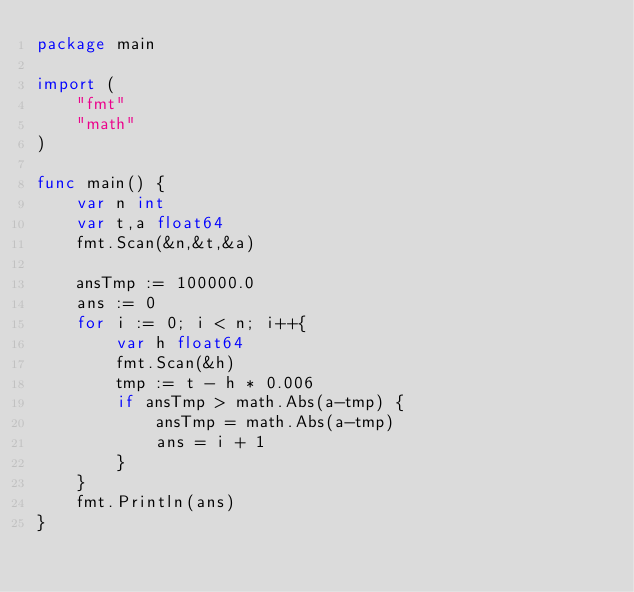<code> <loc_0><loc_0><loc_500><loc_500><_Go_>package main

import (
	"fmt"
	"math"
)

func main() {
	var n int
	var t,a float64
	fmt.Scan(&n,&t,&a)

	ansTmp := 100000.0
	ans := 0
	for i := 0; i < n; i++{
		var h float64
		fmt.Scan(&h)
		tmp := t - h * 0.006
		if ansTmp > math.Abs(a-tmp) {
			ansTmp = math.Abs(a-tmp)
			ans = i + 1
		}
	}
	fmt.Println(ans)
}</code> 